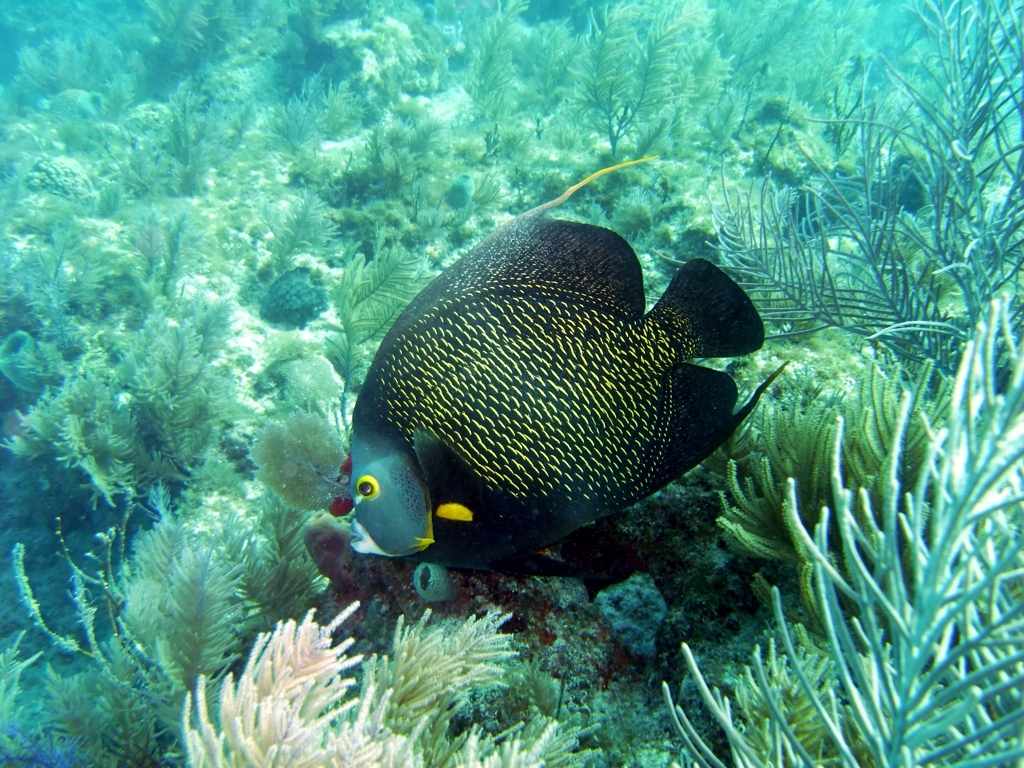Is the underwater environment clear and visible? Yes, the underwater environment appears quite clear and visible, as evidenced by the sharp details captured in the image. We can observe the intricate patterns on a fish's body and the delicate structures of the coral and seaweed with striking clarity, indicative of good visibility underwater. 